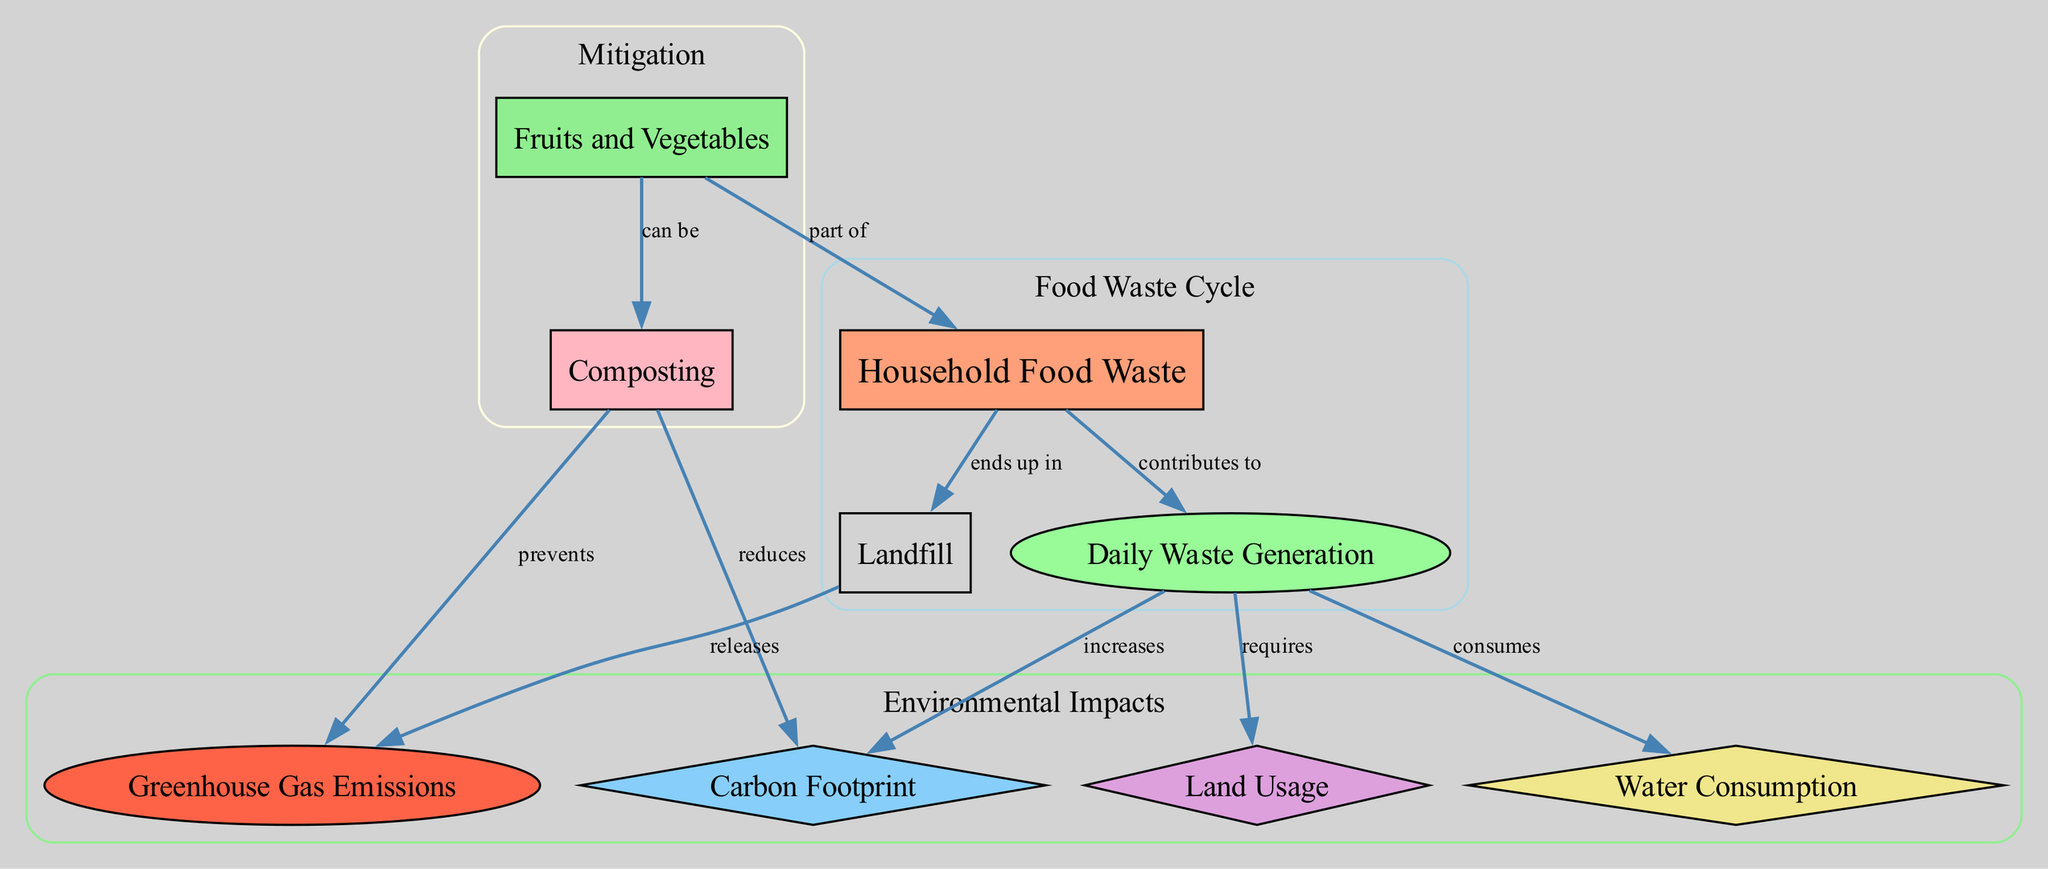What is the node labeled "Household Food Waste"? The node labeled "Household Food Waste" is identified as the starting point of the diagram. It is represented as a box (node ID 1).
Answer: Household Food Waste How many nodes are present in the diagram? By counting the individual nodes listed, there are a total of 9 nodes shown in the diagram.
Answer: 9 What does "Daily Waste Generation" increase? The directed edge labeled "increases" goes from "Daily Waste Generation" (node ID 2) to "Carbon Footprint" (node ID 3), indicating a direct relationship where increasing daily waste generation leads to an increase in carbon footprint.
Answer: Carbon Footprint What happens to the waste that ends up in "Landfill"? The diagram shows that the waste that ends up in "Landfill" (node ID 8) releases "Greenhouse Gas Emissions" (node ID 9), indicating a detrimental impact on the environment.
Answer: Greenhouse Gas Emissions What can fruits and vegetables be part of? The edge connecting "Fruits and Vegetables" (node ID 6) to "Household Food Waste" (node ID 1) indicates that fruits and vegetables can contribute to household food waste.
Answer: part of What does composting prevent? The directed edge from "Composting" (node ID 7) to "Greenhouse Gas Emissions" (node ID 9) indicates that composting has a preventative role regarding greenhouse gas emissions.
Answer: Greenhouse Gas Emissions How does the "Daily Waste Generation" relate to land usage? The directed edge labeled "requires" shows that "Daily Waste Generation" (node ID 2) requires "Land Usage" (node ID 4), meaning the more waste generated, the more land is needed.
Answer: requires What are fruits and vegetables actively involved in? The edge from "Fruits and Vegetables" (node ID 6) to "Composting" (node ID 7) indicates that fruits and vegetables can actively be part of the composting process.
Answer: can be What effect does composting have on carbon footprint? The edge from "Composting" (node ID 7) to "Carbon Footprint" (node ID 3) indicates that composting reduces the carbon footprint, showing a beneficial impact of composting on environmental health.
Answer: reduces 